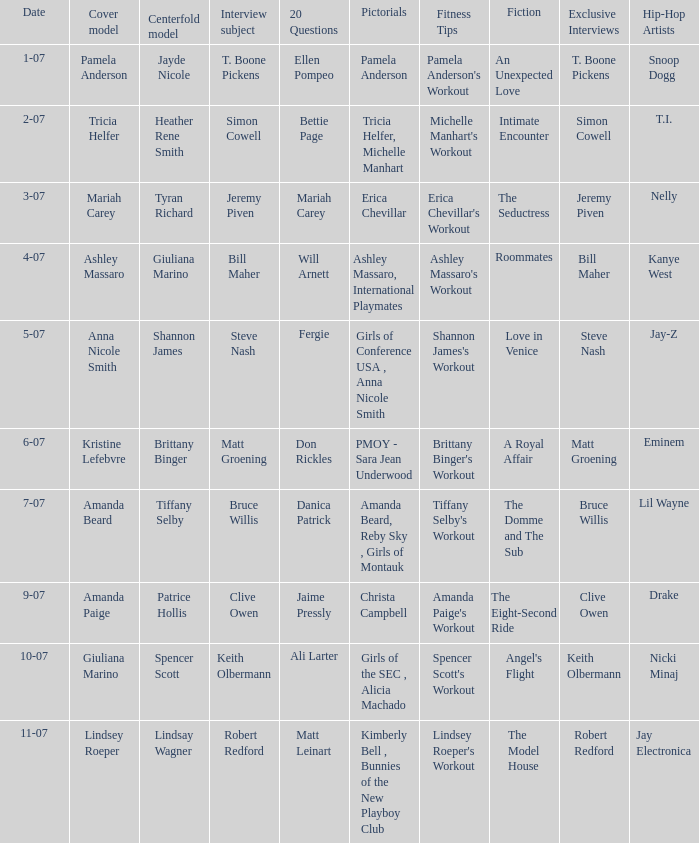Who was the centerfold model when the issue's pictorial was amanda beard, reby sky , girls of montauk ? Tiffany Selby. 